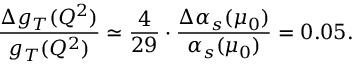<formula> <loc_0><loc_0><loc_500><loc_500>\frac { \Delta g _ { T } ( Q ^ { 2 } ) } { g _ { T } ( Q ^ { 2 } ) } \simeq \frac { 4 } { 2 9 } \cdot \frac { \Delta \alpha _ { s } ( \mu _ { 0 } ) } { \alpha _ { s } ( \mu _ { 0 } ) } = 0 . 0 5 .</formula> 